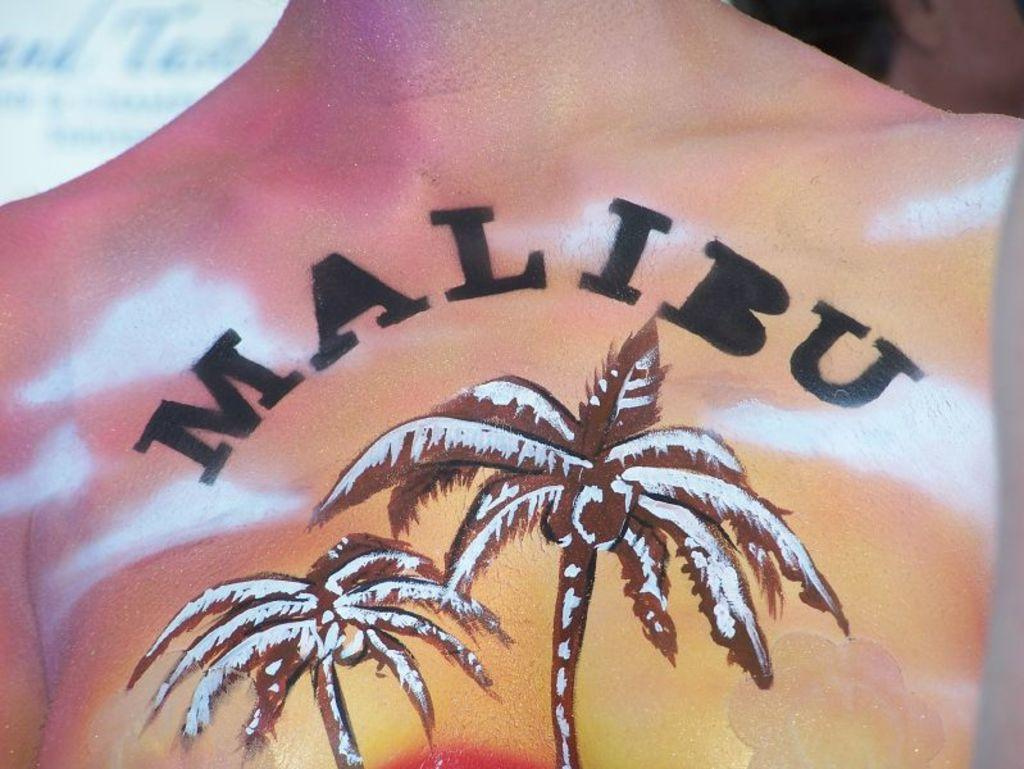What is the main subject of the image? There is a human body in the image. What can be seen on the human body? There is a tattoo on the human body. What type of vegetation is present in the image? There are coconut trees in the image. What else is featured in the image besides the human body and coconut trees? There is text written in the image. What type of flame can be seen on the human body in the image? There is no flame present on the human body in the image. How is the glue used in the image? There is no glue present in the image. 